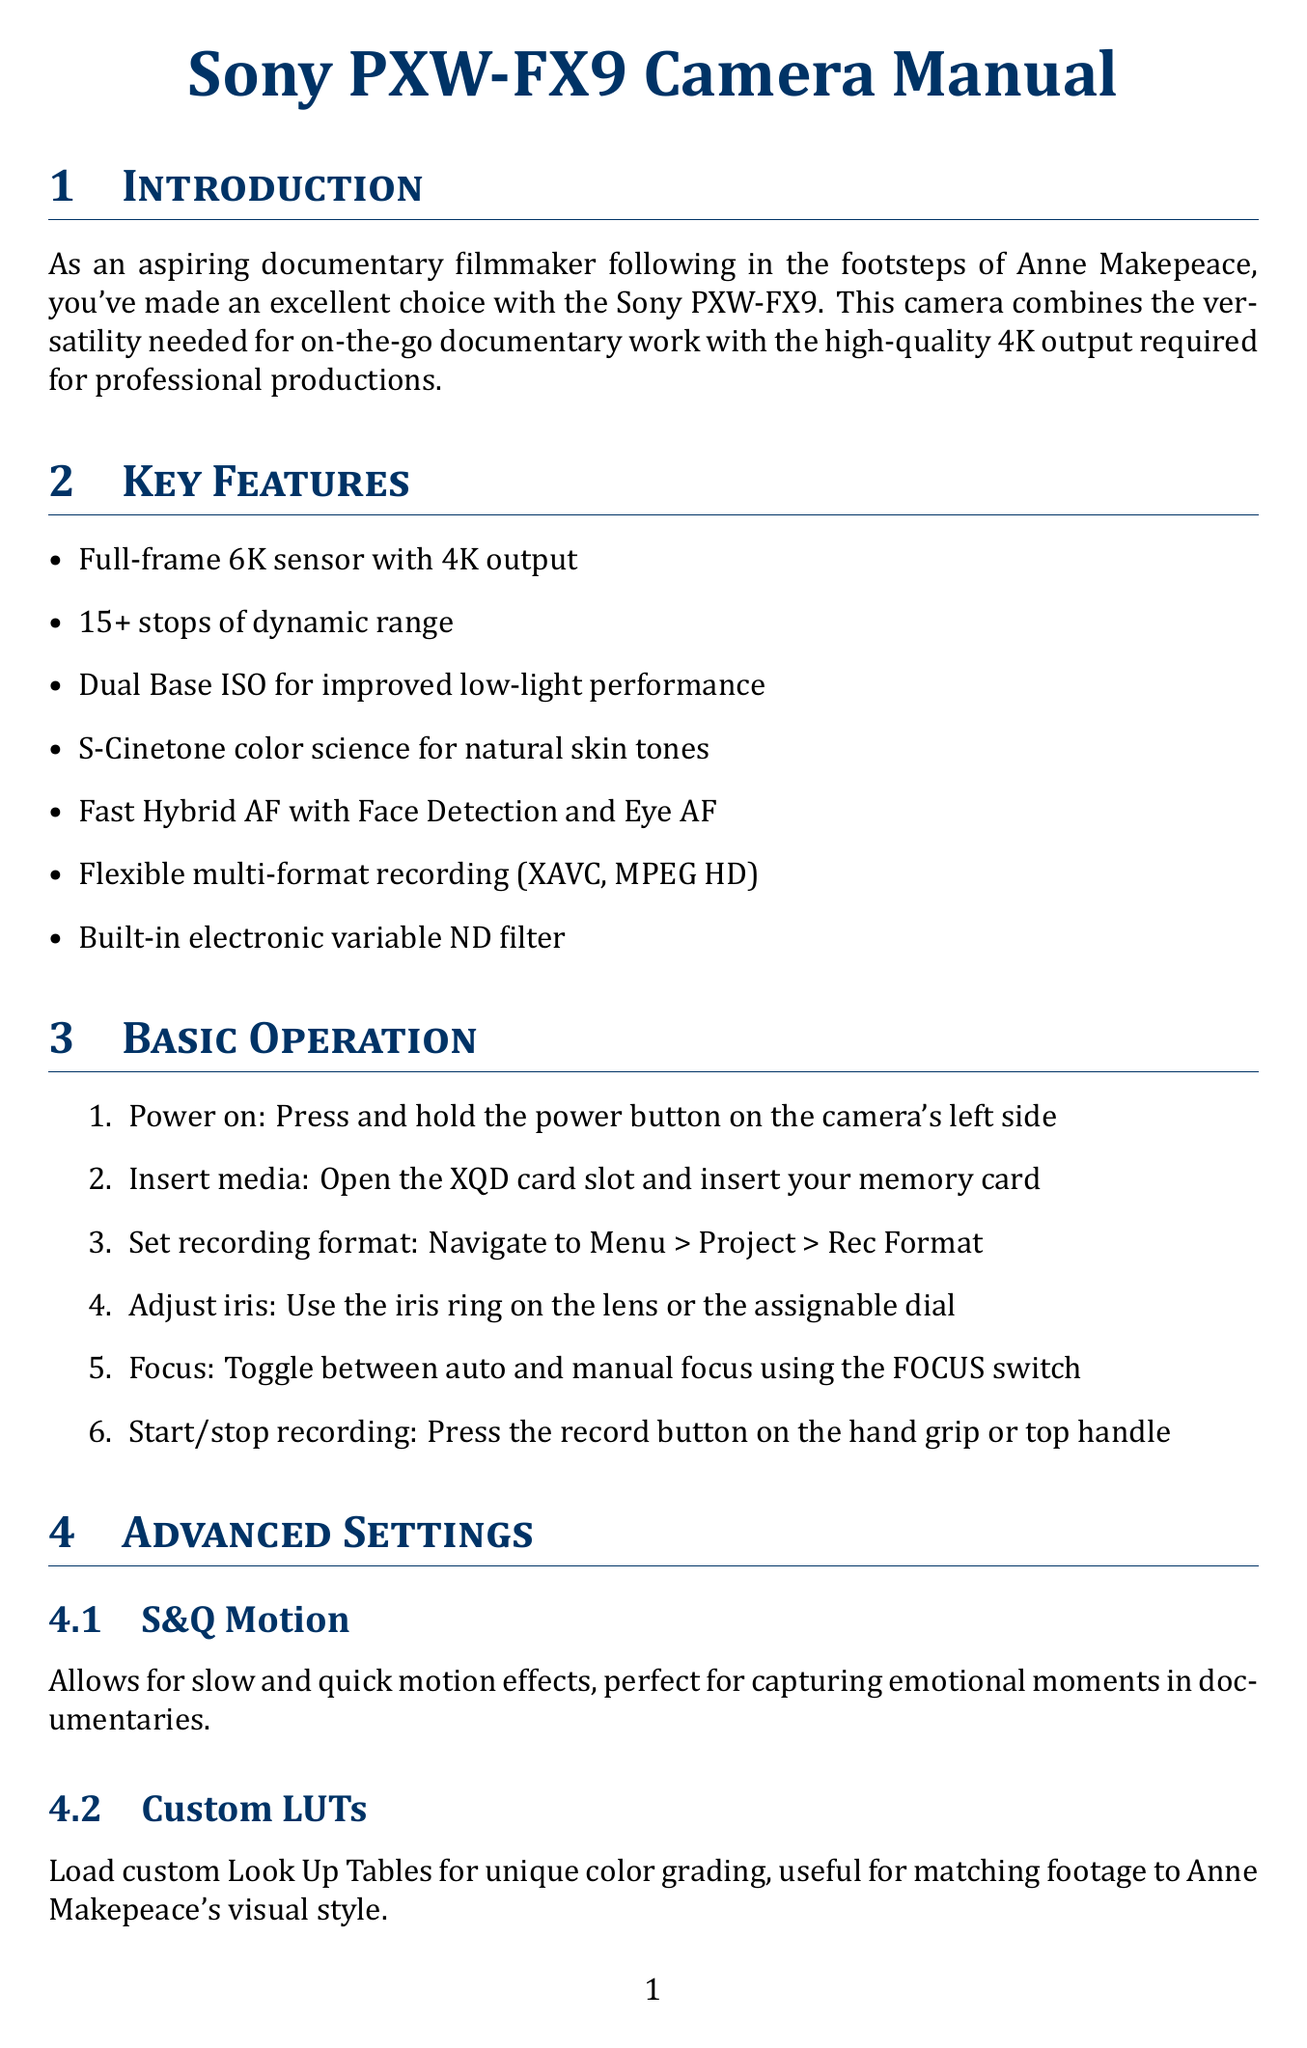what is the camera model? The camera model mentioned in the document is the Sony PXW-FX9.
Answer: Sony PXW-FX9 how many stops of dynamic range does the camera have? The document states that the camera has 15+ stops of dynamic range.
Answer: 15+ what type of sensor does the camera have? According to the document, the camera has a full-frame 6K sensor with 4K output.
Answer: full-frame 6K sensor what is one feature that aids low-light performance? The document mentions Dual Base ISO for improved low-light performance.
Answer: Dual Base ISO what is the purpose of the S&Q Motion setting? The S&Q Motion allows for slow and quick motion effects, enhancing emotional capture in documentaries.
Answer: slow and quick motion effects how should batteries be stored when not in use? The document advises to store batteries in a cool, dry place when not in use.
Answer: cool, dry place what should you do if the camera won't power on? The troubleshooting section suggests ensuring the battery is charged and properly inserted or that the AC adapter is securely connected.
Answer: ensure battery is charged what is a recommended accessory for external 4K recording? The Atomos Ninja V is recommended for external 4K recording and monitoring in the document.
Answer: Atomos Ninja V how can you monitor audio levels? You can monitor audio levels using headphones connected to the headphone jack.
Answer: headphones connected to the headphone jack 